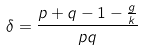Convert formula to latex. <formula><loc_0><loc_0><loc_500><loc_500>\delta = \frac { p + q - 1 - \frac { g } { k } } { p q }</formula> 